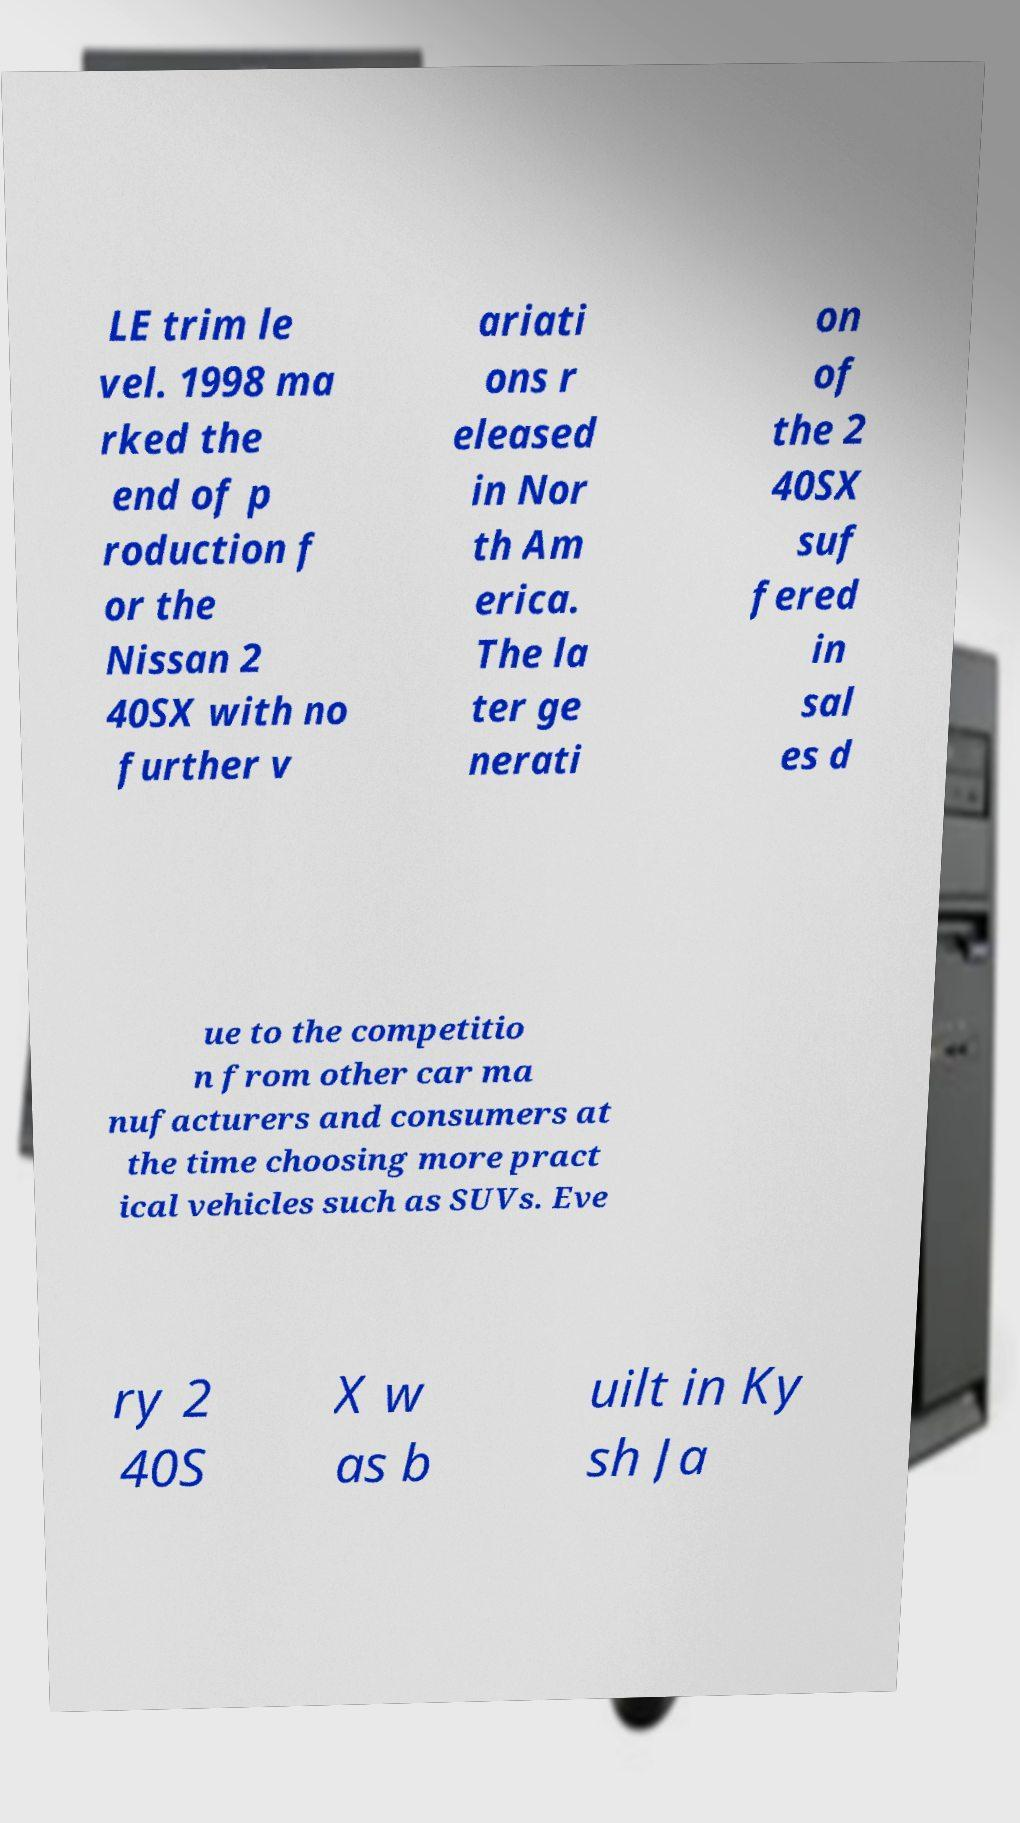Could you extract and type out the text from this image? LE trim le vel. 1998 ma rked the end of p roduction f or the Nissan 2 40SX with no further v ariati ons r eleased in Nor th Am erica. The la ter ge nerati on of the 2 40SX suf fered in sal es d ue to the competitio n from other car ma nufacturers and consumers at the time choosing more pract ical vehicles such as SUVs. Eve ry 2 40S X w as b uilt in Ky sh Ja 